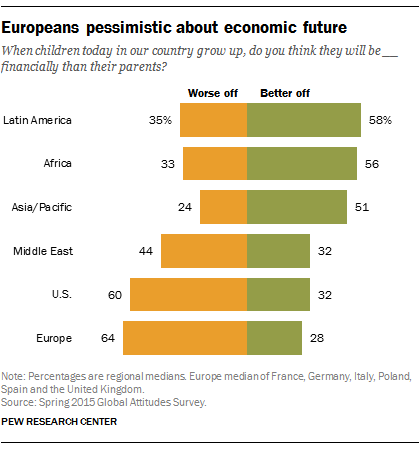Draw attention to some important aspects in this diagram. According to a recent survey, the percentage value of people who believe they are worse off in Latin America is 35%. This indicates a significant proportion of the population is struggling and in need of support and assistance. The median of green bars is greater than the smallest value of orange bars. 